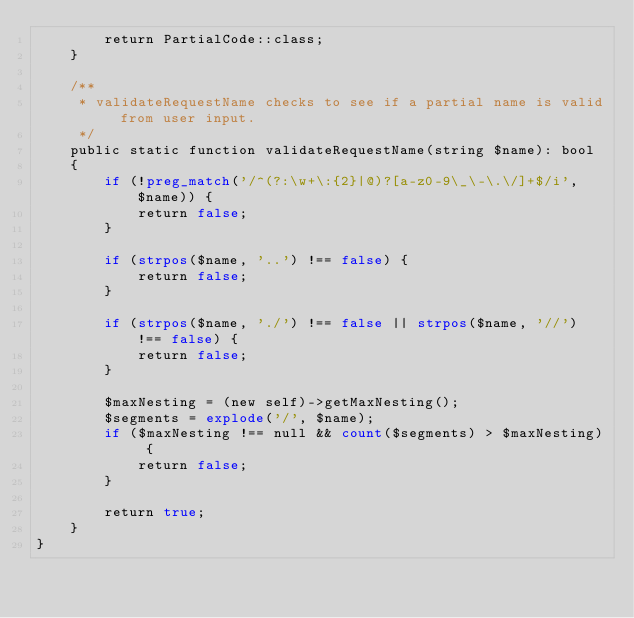Convert code to text. <code><loc_0><loc_0><loc_500><loc_500><_PHP_>        return PartialCode::class;
    }

    /**
     * validateRequestName checks to see if a partial name is valid from user input.
     */
    public static function validateRequestName(string $name): bool
    {
        if (!preg_match('/^(?:\w+\:{2}|@)?[a-z0-9\_\-\.\/]+$/i', $name)) {
            return false;
        }

        if (strpos($name, '..') !== false) {
            return false;
        }

        if (strpos($name, './') !== false || strpos($name, '//') !== false) {
            return false;
        }

        $maxNesting = (new self)->getMaxNesting();
        $segments = explode('/', $name);
        if ($maxNesting !== null && count($segments) > $maxNesting) {
            return false;
        }

        return true;
    }
}
</code> 